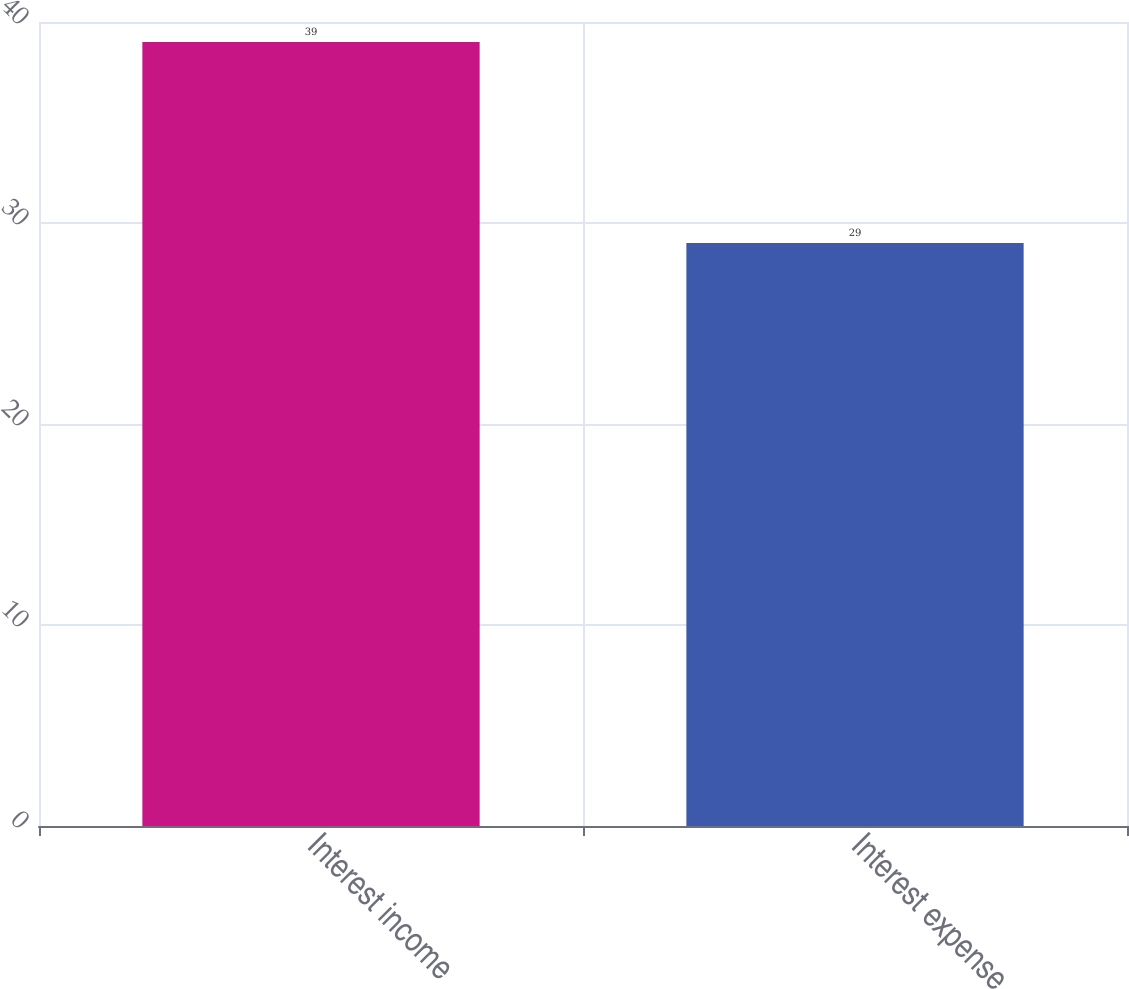<chart> <loc_0><loc_0><loc_500><loc_500><bar_chart><fcel>Interest income<fcel>Interest expense<nl><fcel>39<fcel>29<nl></chart> 